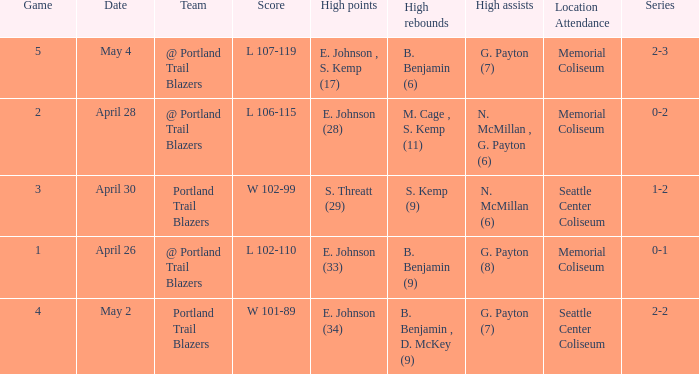With a 0-2 series, what is the high points? E. Johnson (28). 